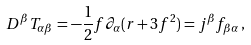Convert formula to latex. <formula><loc_0><loc_0><loc_500><loc_500>D ^ { \beta } T _ { \alpha \beta } = - \frac { 1 } { 2 } f \partial _ { \alpha } ( r + 3 f ^ { 2 } ) = j ^ { \beta } f _ { \beta \alpha } \, ,</formula> 